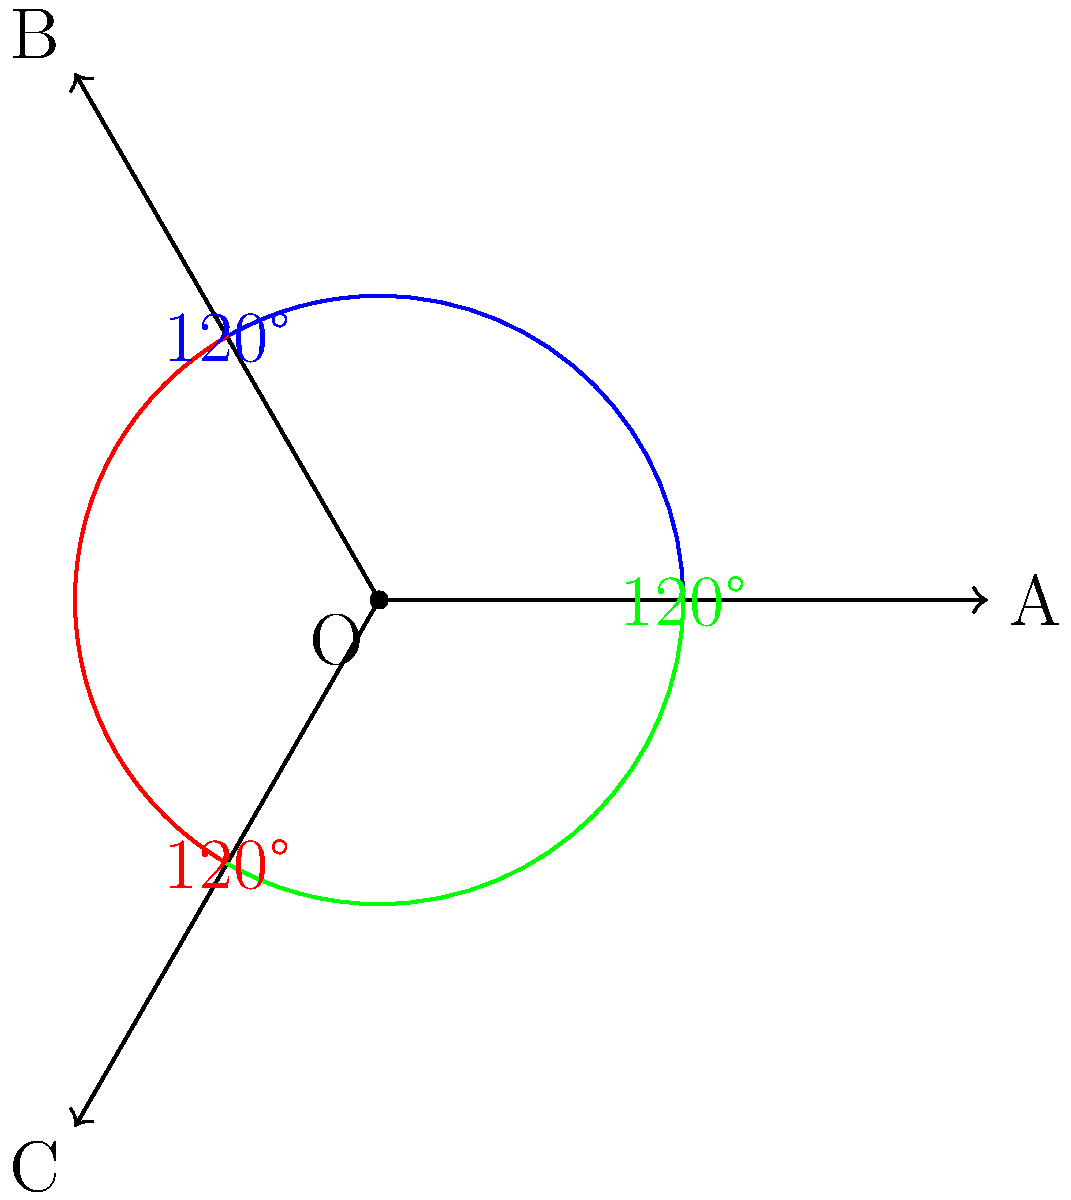In a top-down strategy game, you're implementing a radar system for units. Each unit has a 120° field of view, divided into three equal sectors. If a unit is facing east (0°), what are the angle ranges for each sector, and how would you determine if a detected object falls within a specific sector? To solve this problem, let's break it down into steps:

1. Understanding the setup:
   - The unit is facing east (0°)
   - Total field of view is 120°
   - There are three equal sectors

2. Calculating sector angles:
   - Each sector is 120° ÷ 3 = 40°

3. Determining angle ranges for each sector:
   - Sector 1: 0° to 40°
   - Sector 2: 40° to 80°
   - Sector 3: 80° to 120°

4. Checking if an object is in a specific sector:
   - Get the angle between the unit and the object (let's call it θ)
   - Use the following conditions:
     * If 0° ≤ θ < 40°, object is in Sector 1
     * If 40° ≤ θ < 80°, object is in Sector 2
     * If 80° ≤ θ < 120°, object is in Sector 3

5. Implementing in code (pseudocode):
   ```
   function checkSector(objectAngle):
       if 0 <= objectAngle < 40:
           return 1
       else if 40 <= objectAngle < 80:
           return 2
       else if 80 <= objectAngle < 120:
           return 3
       else:
           return 0  // Object is outside the field of view
   ```

6. Handling angles greater than 360°:
   - Use the modulo operator to wrap angles:
     objectAngle = objectAngle % 360

7. Adjusting for unit rotation:
   - If the unit is not facing east, add the unit's rotation angle to the object angle before checking:
     objectAngle = (objectAngle + unitRotation) % 360

By following these steps, you can determine which sector an object falls into within the unit's field of view.
Answer: Sector 1: 0°-40°, Sector 2: 40°-80°, Sector 3: 80°-120°. Check using: if (0 ≤ θ < 40) Sector 1; else if (40 ≤ θ < 80) Sector 2; else if (80 ≤ θ < 120) Sector 3. 